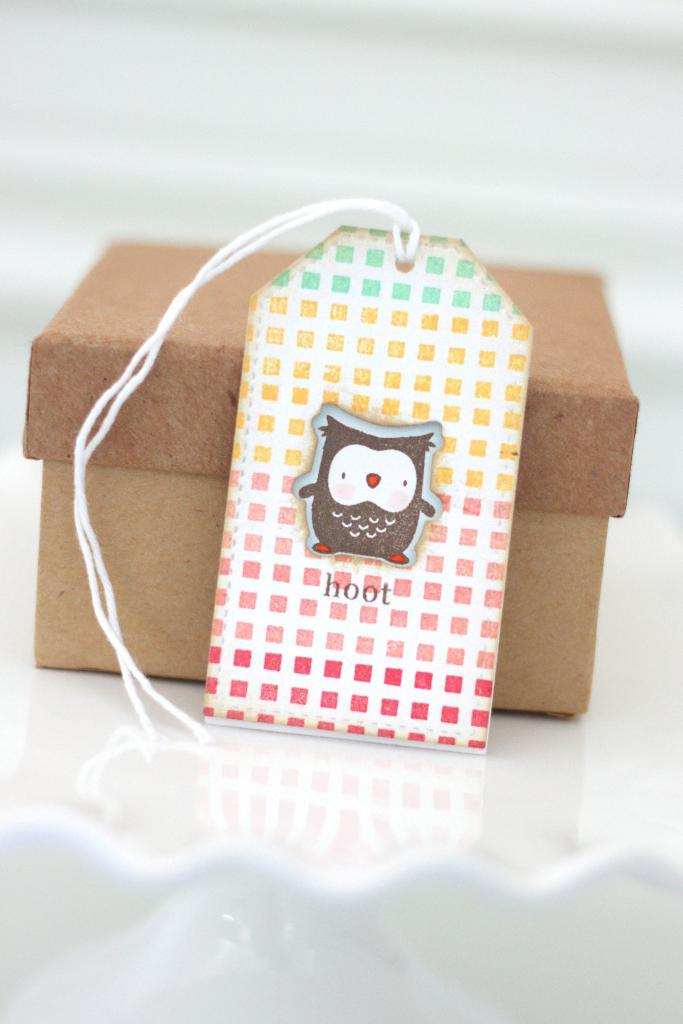What object can be seen in the image? There is a box in the image. What is placed in front of the box? There is a card with thread in front of the box. What type of paint is used to create the card in the image? There is no paint mentioned or visible in the image; it only shows a card with thread in front of a box. 